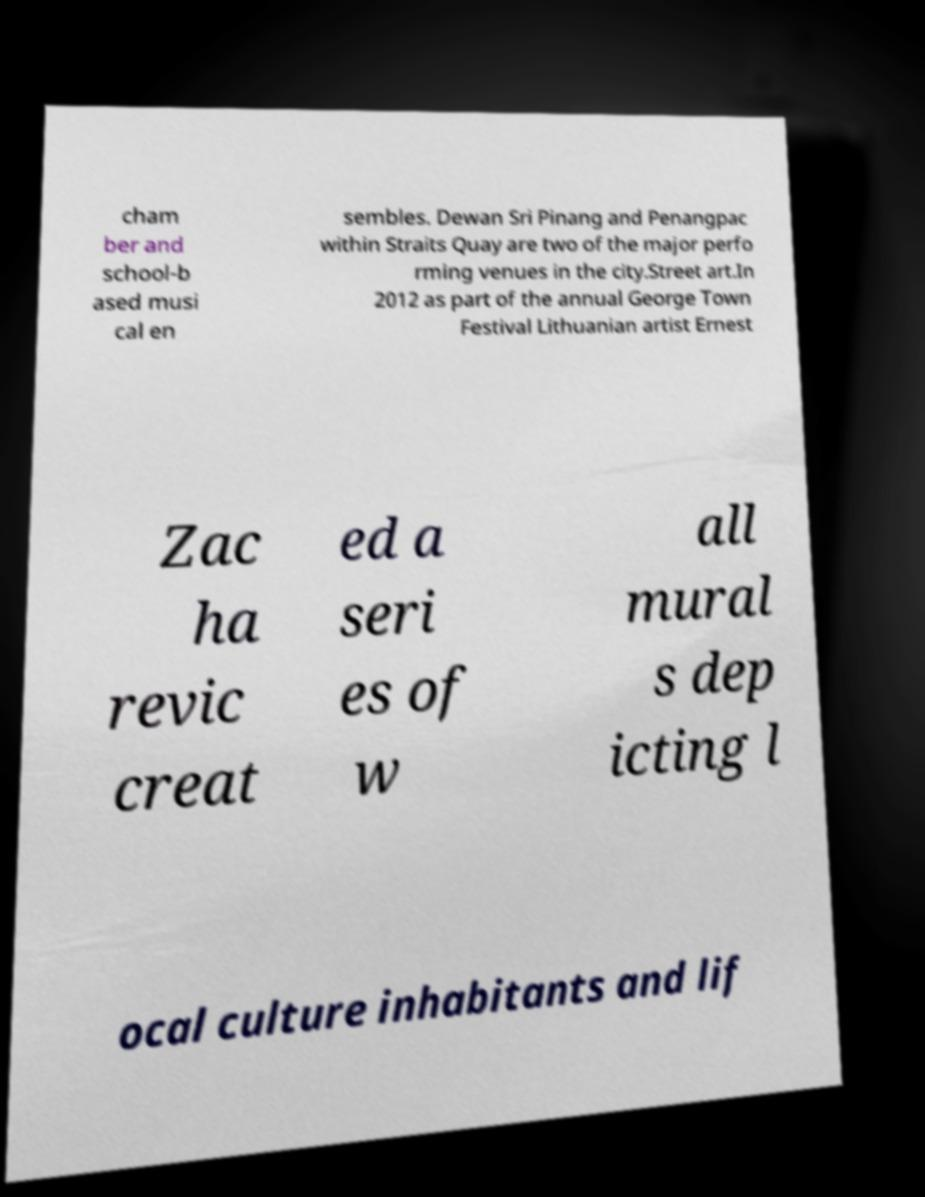There's text embedded in this image that I need extracted. Can you transcribe it verbatim? cham ber and school-b ased musi cal en sembles. Dewan Sri Pinang and Penangpac within Straits Quay are two of the major perfo rming venues in the city.Street art.In 2012 as part of the annual George Town Festival Lithuanian artist Ernest Zac ha revic creat ed a seri es of w all mural s dep icting l ocal culture inhabitants and lif 